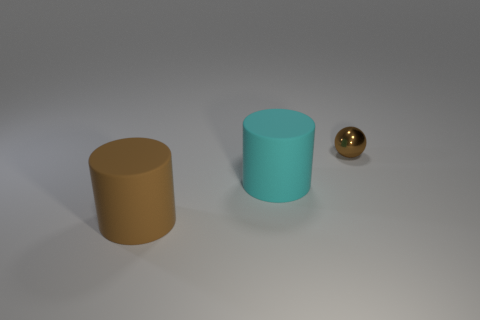Add 3 big cyan rubber balls. How many objects exist? 6 Subtract all cylinders. How many objects are left? 1 Add 3 small red rubber spheres. How many small red rubber spheres exist? 3 Subtract 0 purple cylinders. How many objects are left? 3 Subtract all tiny brown metallic objects. Subtract all tiny brown shiny spheres. How many objects are left? 1 Add 2 large brown things. How many large brown things are left? 3 